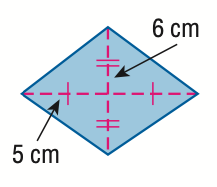Answer the mathemtical geometry problem and directly provide the correct option letter.
Question: Find the area of the rhombus.
Choices: A: 22 B: 30 C: 60 D: 120 C 